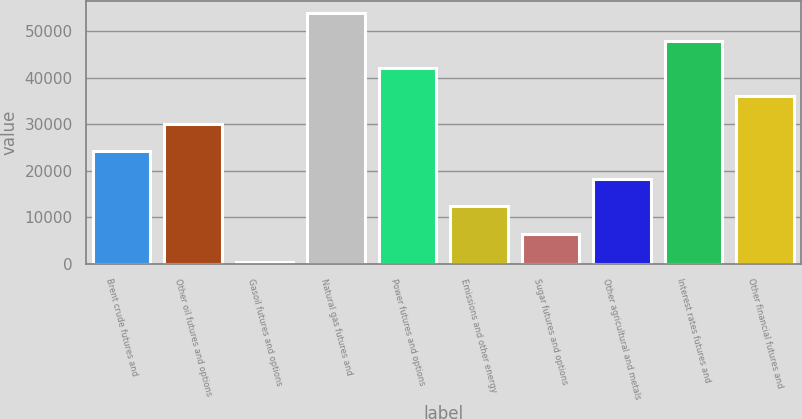<chart> <loc_0><loc_0><loc_500><loc_500><bar_chart><fcel>Brent crude futures and<fcel>Other oil futures and options<fcel>Gasoil futures and options<fcel>Natural gas futures and<fcel>Power futures and options<fcel>Emissions and other energy<fcel>Sugar futures and options<fcel>Other agricultural and metals<fcel>Interest rates futures and<fcel>Other financial futures and<nl><fcel>24200<fcel>30118.5<fcel>526<fcel>53792.5<fcel>41955.5<fcel>12363<fcel>6444.5<fcel>18281.5<fcel>47874<fcel>36037<nl></chart> 